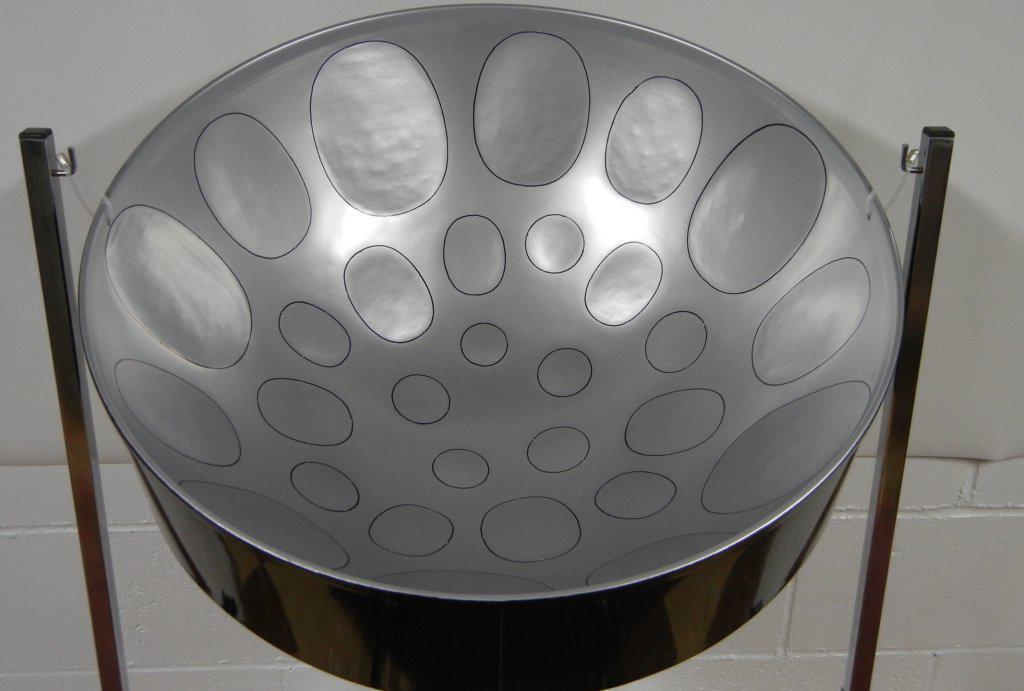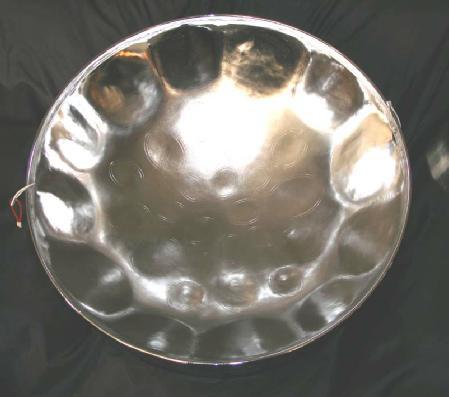The first image is the image on the left, the second image is the image on the right. Analyze the images presented: Is the assertion "There are two drum stick laying in the middle of an inverted metal drum." valid? Answer yes or no. No. The first image is the image on the left, the second image is the image on the right. Evaluate the accuracy of this statement regarding the images: "The right image shows the interior of a concave metal drum, with a pair of drumsticks in its bowl.". Is it true? Answer yes or no. No. 